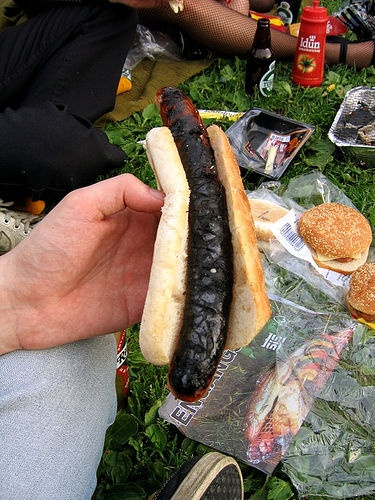Describe the objects in this image and their specific colors. I can see hot dog in darkgreen, black, tan, beige, and gray tones, people in darkgreen, salmon, and brown tones, people in darkgreen, black, gray, lightpink, and darkgray tones, people in darkgreen, black, brown, and maroon tones, and sandwich in darkgreen, orange, tan, and red tones in this image. 